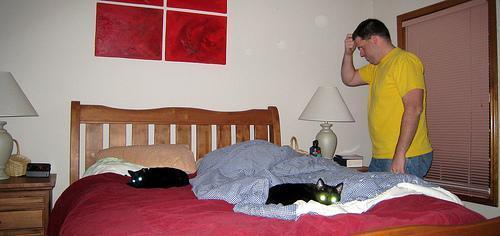How many cats are laying on the red blanket?
Give a very brief answer. 1. 